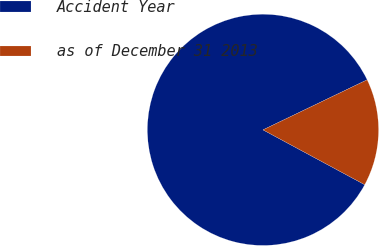<chart> <loc_0><loc_0><loc_500><loc_500><pie_chart><fcel>Accident Year<fcel>as of December 31 2013<nl><fcel>85.0%<fcel>15.0%<nl></chart> 